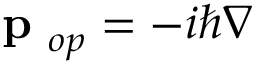Convert formula to latex. <formula><loc_0><loc_0><loc_500><loc_500>p _ { o p } = - i \hbar { \nabla }</formula> 